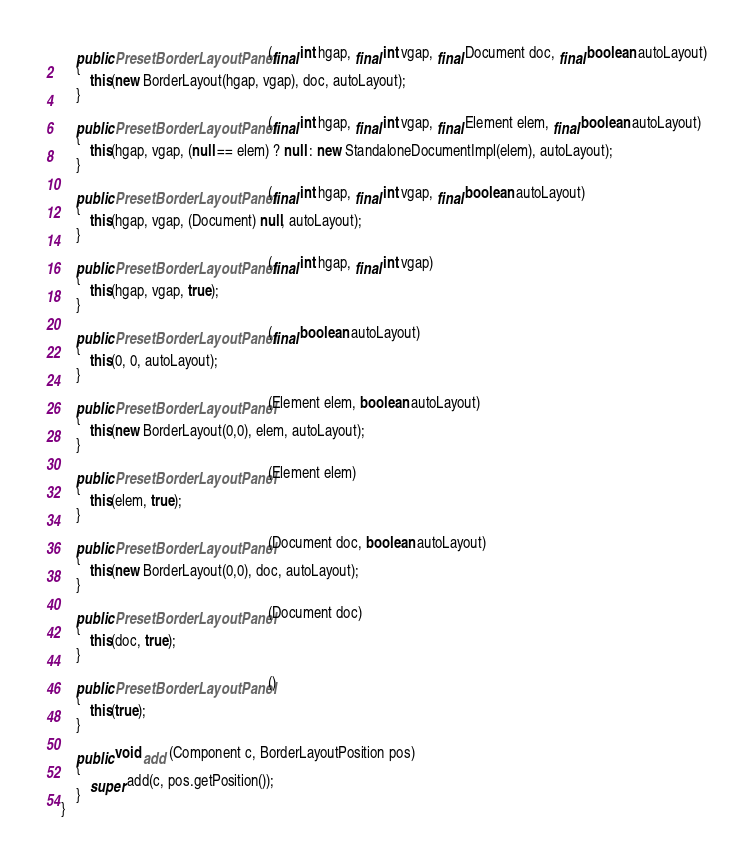Convert code to text. <code><loc_0><loc_0><loc_500><loc_500><_Java_>    public PresetBorderLayoutPanel (final int hgap, final int vgap, final Document doc, final boolean autoLayout)
    {
        this(new BorderLayout(hgap, vgap), doc, autoLayout);
    }

    public PresetBorderLayoutPanel (final int hgap, final int vgap, final Element elem, final boolean autoLayout)
    {
        this(hgap, vgap, (null == elem) ? null : new StandaloneDocumentImpl(elem), autoLayout);
    }

    public PresetBorderLayoutPanel (final int hgap, final int vgap, final boolean autoLayout)
    {
        this(hgap, vgap, (Document) null, autoLayout);
    }

    public PresetBorderLayoutPanel (final int hgap, final int vgap)
    {
        this(hgap, vgap, true);
    }

    public PresetBorderLayoutPanel (final boolean autoLayout)
    {
        this(0, 0, autoLayout);
    }

    public PresetBorderLayoutPanel (Element elem, boolean autoLayout)
    {
        this(new BorderLayout(0,0), elem, autoLayout);
    }

    public PresetBorderLayoutPanel (Element elem)
    {
        this(elem, true);
    }

    public PresetBorderLayoutPanel (Document doc, boolean autoLayout)
    {
        this(new BorderLayout(0,0), doc, autoLayout);
    }

    public PresetBorderLayoutPanel (Document doc)
    {
        this(doc, true);
    }

    public PresetBorderLayoutPanel ()
    {
        this(true);
    }

    public void add (Component c, BorderLayoutPosition pos)
    {
        super.add(c, pos.getPosition());
    }
}
</code> 